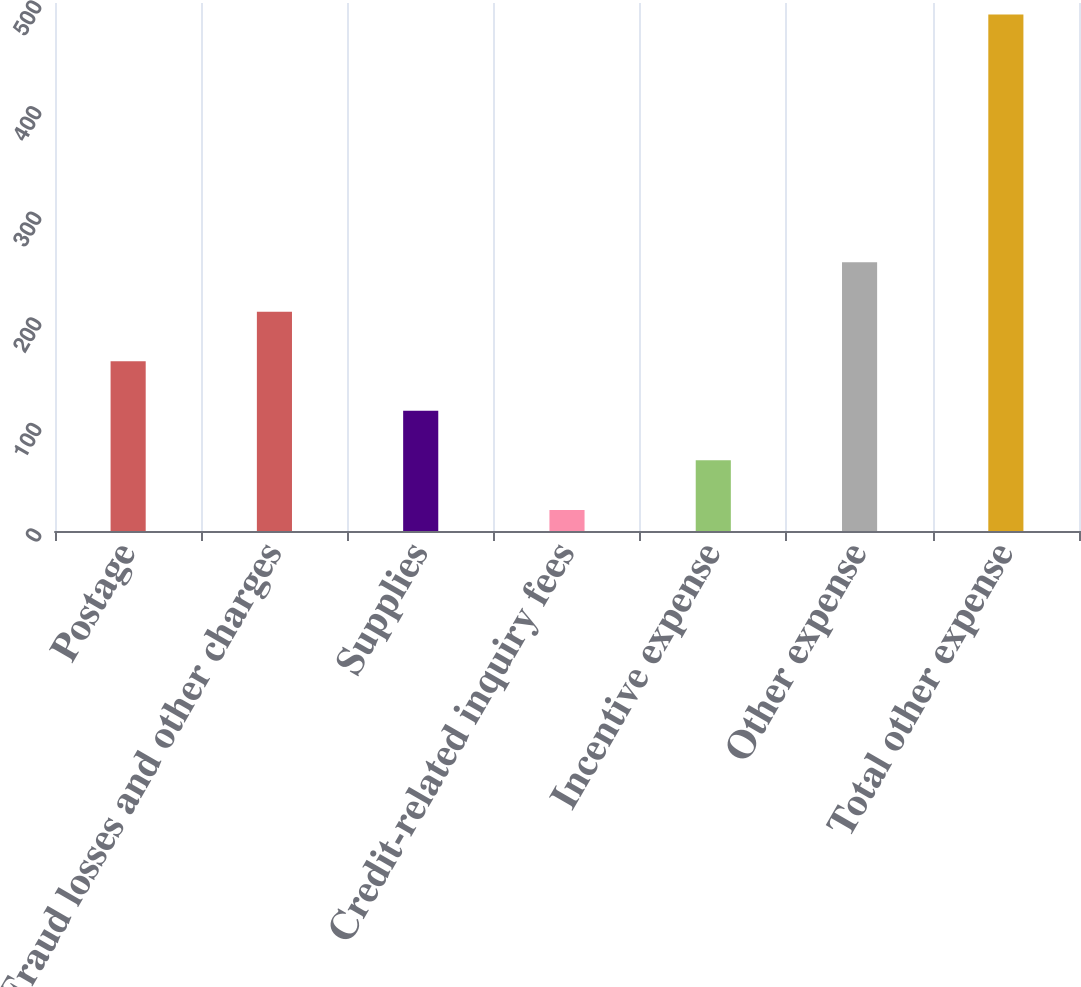<chart> <loc_0><loc_0><loc_500><loc_500><bar_chart><fcel>Postage<fcel>Fraud losses and other charges<fcel>Supplies<fcel>Credit-related inquiry fees<fcel>Incentive expense<fcel>Other expense<fcel>Total other expense<nl><fcel>160.7<fcel>207.6<fcel>113.8<fcel>20<fcel>66.9<fcel>254.5<fcel>489<nl></chart> 